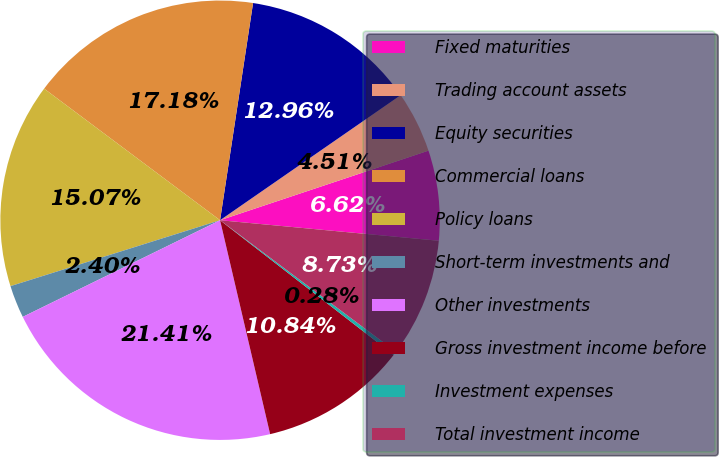Convert chart to OTSL. <chart><loc_0><loc_0><loc_500><loc_500><pie_chart><fcel>Fixed maturities<fcel>Trading account assets<fcel>Equity securities<fcel>Commercial loans<fcel>Policy loans<fcel>Short-term investments and<fcel>Other investments<fcel>Gross investment income before<fcel>Investment expenses<fcel>Total investment income<nl><fcel>6.62%<fcel>4.51%<fcel>12.96%<fcel>17.18%<fcel>15.07%<fcel>2.4%<fcel>21.41%<fcel>10.84%<fcel>0.28%<fcel>8.73%<nl></chart> 